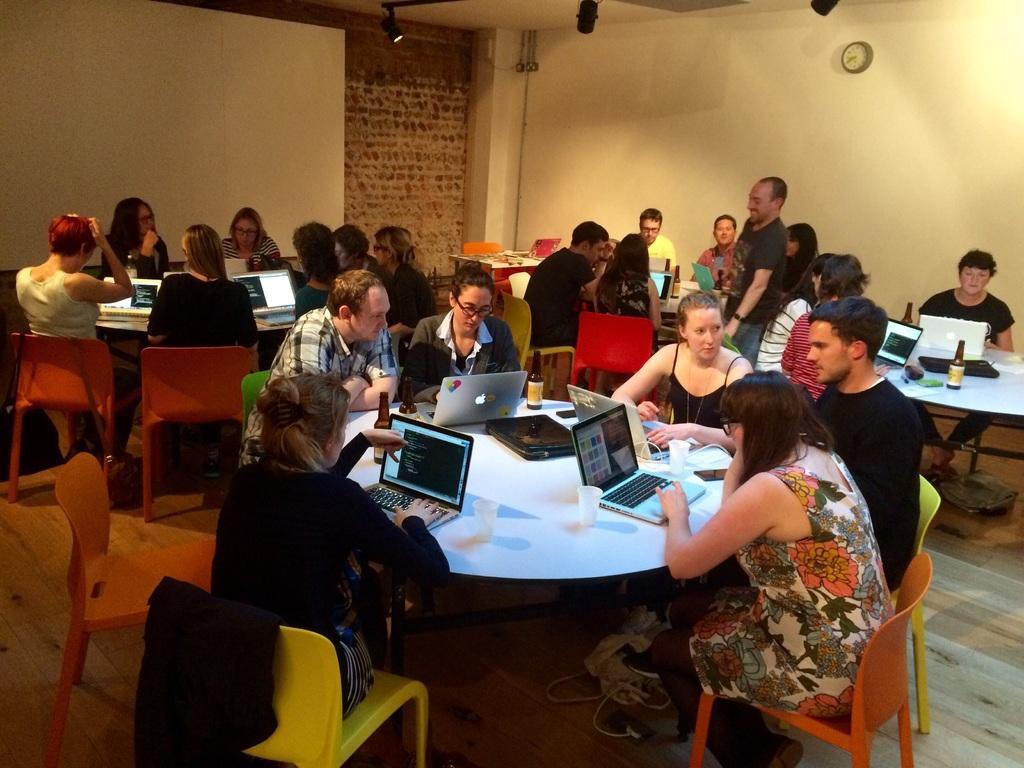How would you summarize this image in a sentence or two? The image is taken inside a room. In the image there are group of people sitting on chair in front of a table, on table we can see a laptop,glass,bottle. On right side there is a man wearing a black color shirt standing and he is also having smile on his face. In background there is a wall which is in cream color and we can also see a clock which is attached to a wall on top there is a roof with few lights. 